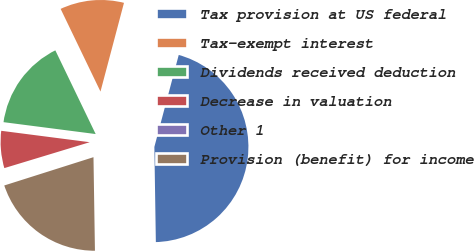Convert chart. <chart><loc_0><loc_0><loc_500><loc_500><pie_chart><fcel>Tax provision at US federal<fcel>Tax-exempt interest<fcel>Dividends received deduction<fcel>Decrease in valuation<fcel>Other 1<fcel>Provision (benefit) for income<nl><fcel>45.63%<fcel>11.27%<fcel>15.81%<fcel>6.73%<fcel>0.2%<fcel>20.36%<nl></chart> 